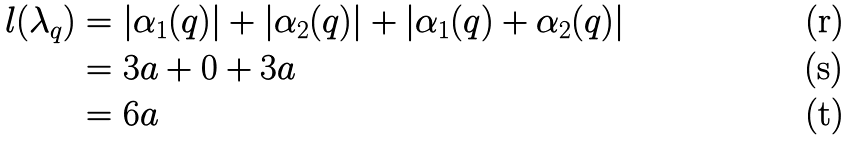Convert formula to latex. <formula><loc_0><loc_0><loc_500><loc_500>l ( \lambda _ { q } ) & = | \alpha _ { 1 } ( q ) | + | \alpha _ { 2 } ( q ) | + | \alpha _ { 1 } ( q ) + \alpha _ { 2 } ( q ) | \\ & = 3 a + 0 + 3 a \\ & = 6 a</formula> 